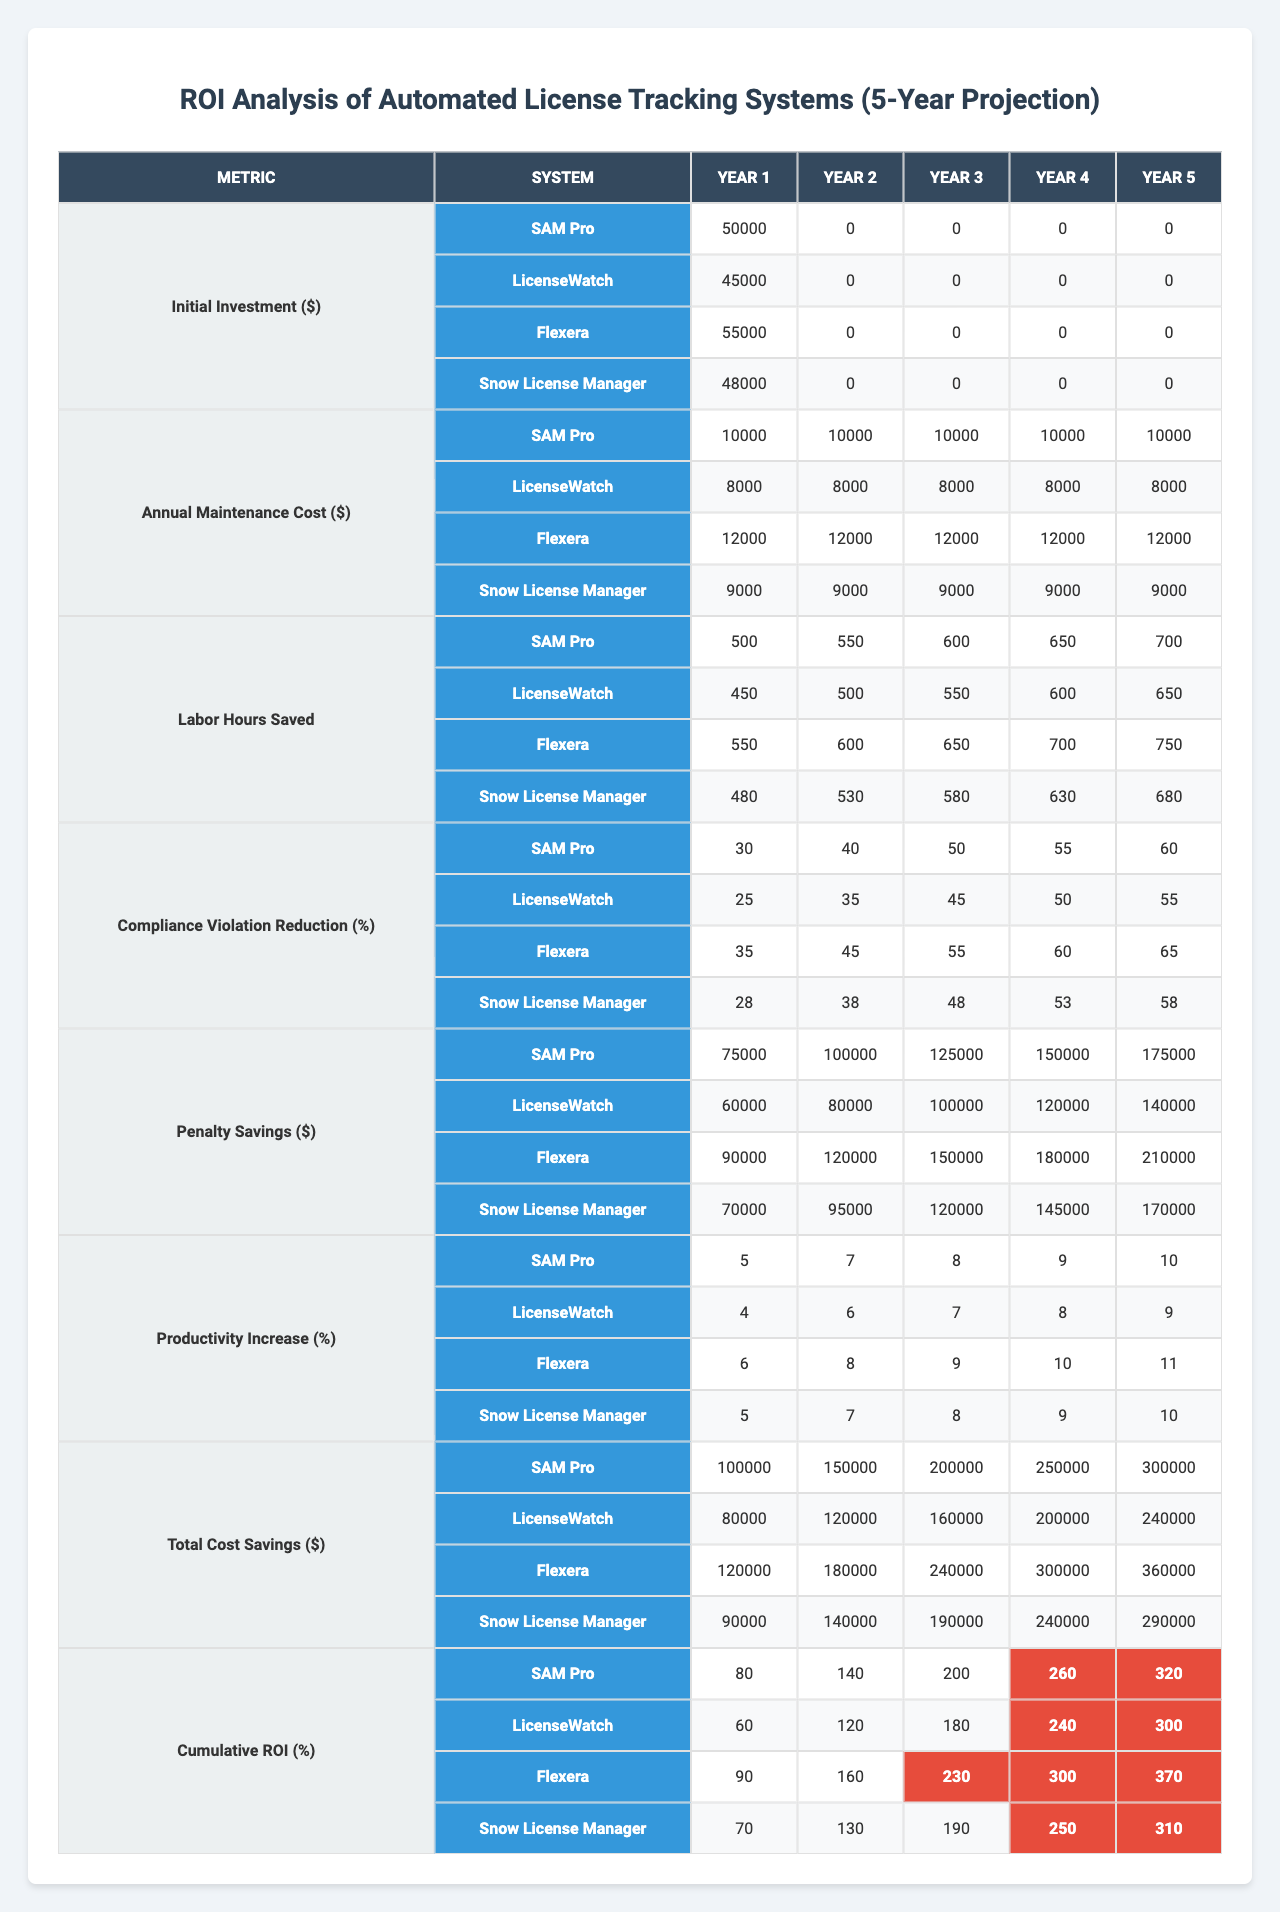What is the initial investment for SAM Pro in year 1? The table shows that the initial investment for SAM Pro in year 1 is listed under the corresponding metric and year. The value is 50,000.
Answer: 50,000 What are the annual maintenance costs for LicenseWatch in year 3? When looking at the table, the annual maintenance cost for LicenseWatch in year 3 is found in the relevant column and row, showing a value of 8,000.
Answer: 8,000 Which system has the highest cumulative ROI in year 5? To determine the highest cumulative ROI in year 5, we compare the values for each system in the cumulative ROI (%) column for year 5. SAM Pro has the highest value at 320%.
Answer: SAM Pro What is the total cost savings for Flexera in year 4? By checking the table, the total cost savings for Flexera in year 4 is found in the appropriate cell, which is 300,000.
Answer: 300,000 Is the penalty savings for Snow License Manager greater than or equal to 150,000 in any year? Looking at the penalty savings for Snow License Manager across all years, the values are 70,000, 95,000, 120,000, 145,000, and 170,000. In year 5, it is greater than 150,000, but the rest are not. Thus, the answer is yes for year 5 only.
Answer: Yes (in year 5) What is the average productivity increase for SAM Pro over the 5 years? To find the average productivity increase for SAM Pro, add the yearly productivity values (5, 7, 8, 9, 10), which totals to 39. Then, divide by 5: 39/5 = 7.8.
Answer: 7.8 Which system has the lowest labor hours saved in year 1? By examining the table for labor hours saved in year 1, we compare the values for all systems: SAM Pro (500), LicenseWatch (450), Flexera (550), and Snow License Manager (480). LicenseWatch has the lowest at 450 hours saved.
Answer: LicenseWatch What is the cumulative ROI for Flexera after 3 years? To find the cumulative ROI for Flexera after 3 years, we look at the corresponding cumulative ROI (%) column for year 3, which shows a value of 230%.
Answer: 230% How much penalty savings did LicenseWatch achieve by year 4? In year 4, we check the penalty savings for LicenseWatch, located in the respective cell in the table. The amount is 120,000.
Answer: 120,000 For which system did compliance violation reduction exceed 50% in year 5? By evaluating the compliance violation reduction values for each system in year 5, we find that SAM Pro (60%), Flexera (65%), and LicenseWatch (55%) exceed 50%. Snow License Manager does not exceed that.
Answer: SAM Pro, Flexera, LicenseWatch 